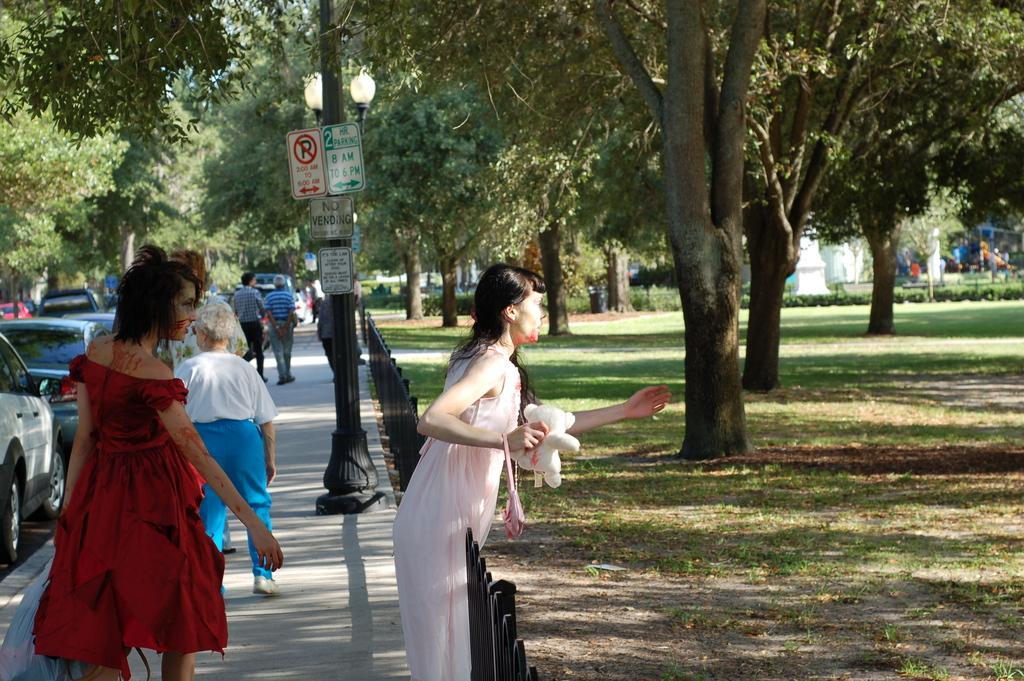Describe this image in one or two sentences. In this image I see the path and I see few people and I see that this woman is holding a soft toy in her hand and I see a pole over here on which there are boards and I see something is written and I see number of cars. In the background I see number of trees and I see the plants and the grass. 